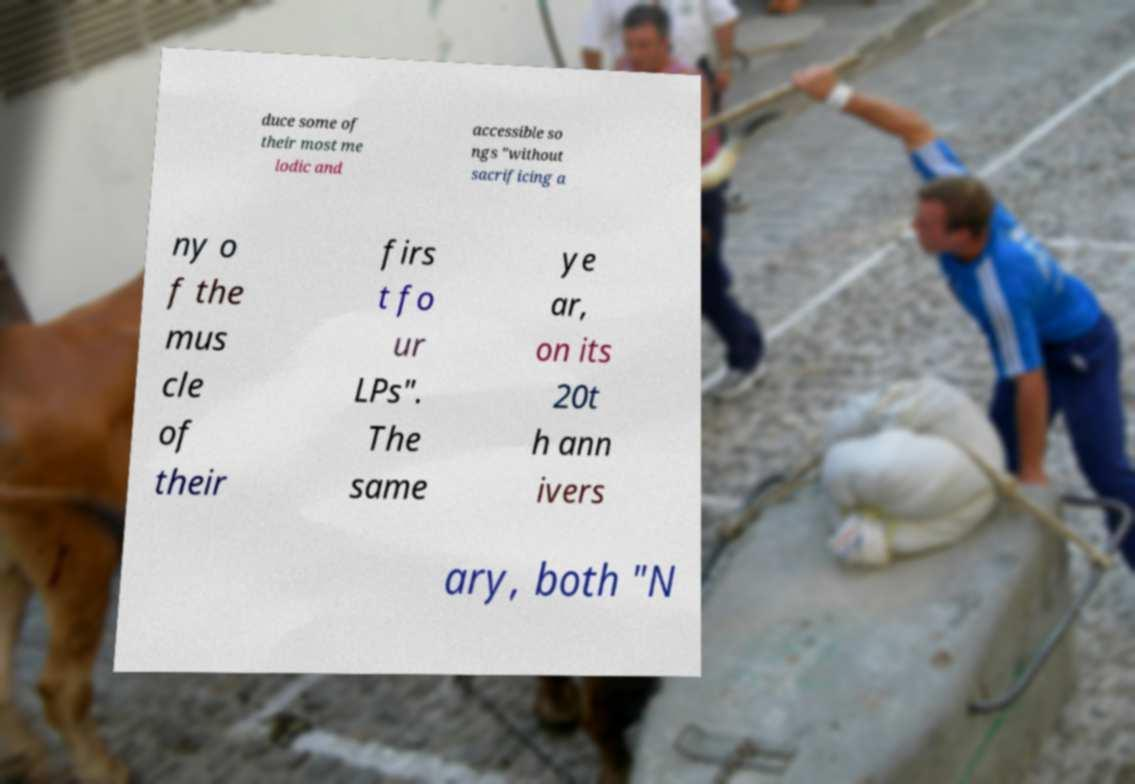Please read and relay the text visible in this image. What does it say? duce some of their most me lodic and accessible so ngs "without sacrificing a ny o f the mus cle of their firs t fo ur LPs". The same ye ar, on its 20t h ann ivers ary, both "N 